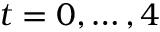Convert formula to latex. <formula><loc_0><loc_0><loc_500><loc_500>t = 0 , \dots , 4</formula> 